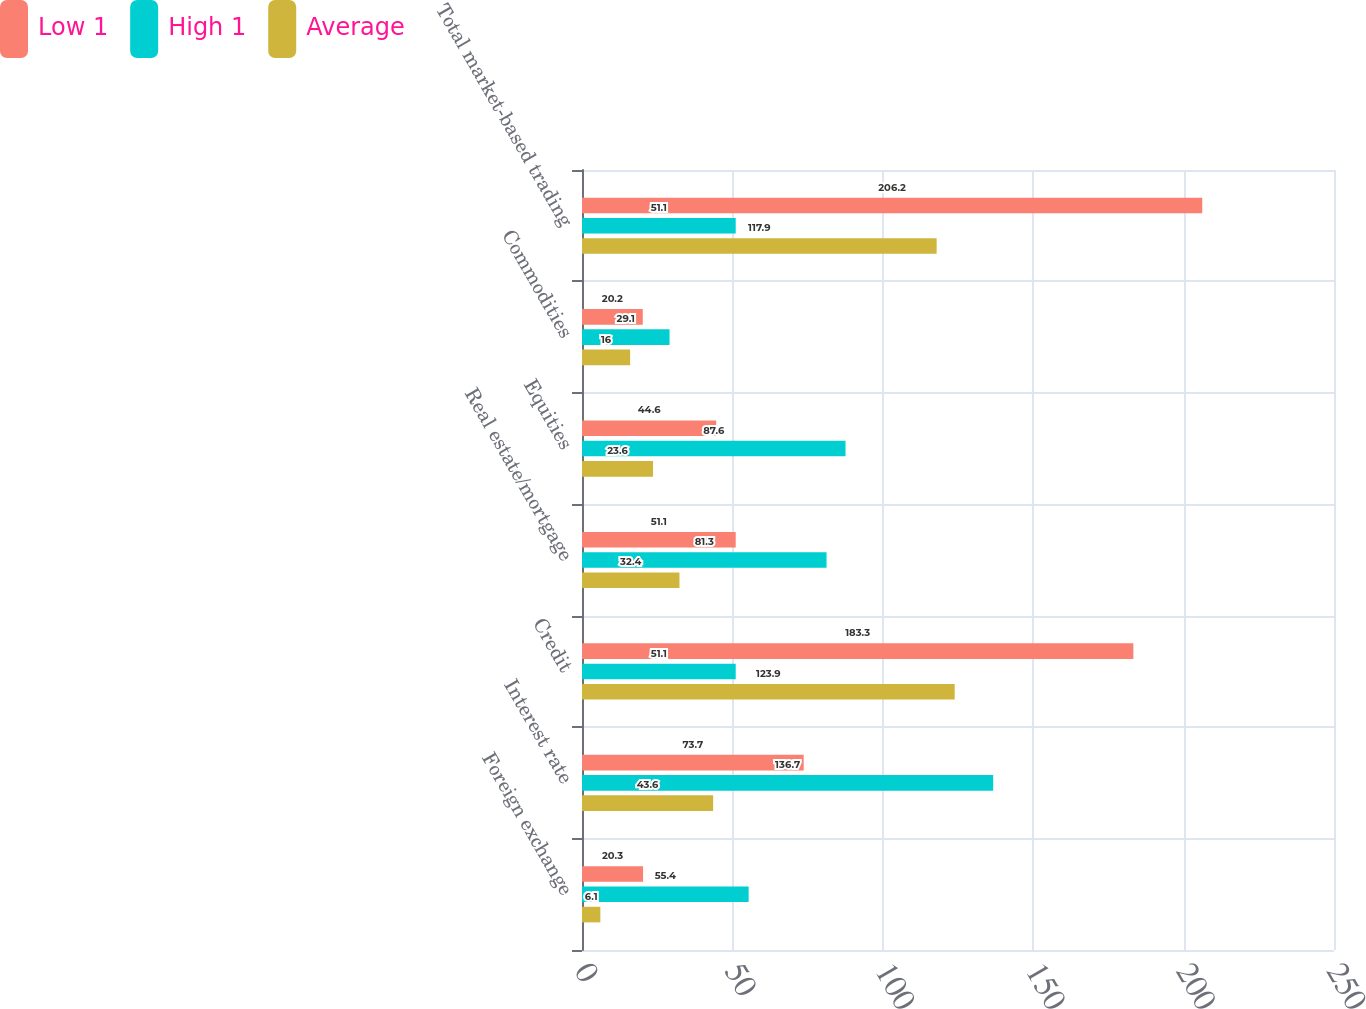Convert chart to OTSL. <chart><loc_0><loc_0><loc_500><loc_500><stacked_bar_chart><ecel><fcel>Foreign exchange<fcel>Interest rate<fcel>Credit<fcel>Real estate/mortgage<fcel>Equities<fcel>Commodities<fcel>Total market-based trading<nl><fcel>Low 1<fcel>20.3<fcel>73.7<fcel>183.3<fcel>51.1<fcel>44.6<fcel>20.2<fcel>206.2<nl><fcel>High 1<fcel>55.4<fcel>136.7<fcel>51.1<fcel>81.3<fcel>87.6<fcel>29.1<fcel>51.1<nl><fcel>Average<fcel>6.1<fcel>43.6<fcel>123.9<fcel>32.4<fcel>23.6<fcel>16<fcel>117.9<nl></chart> 